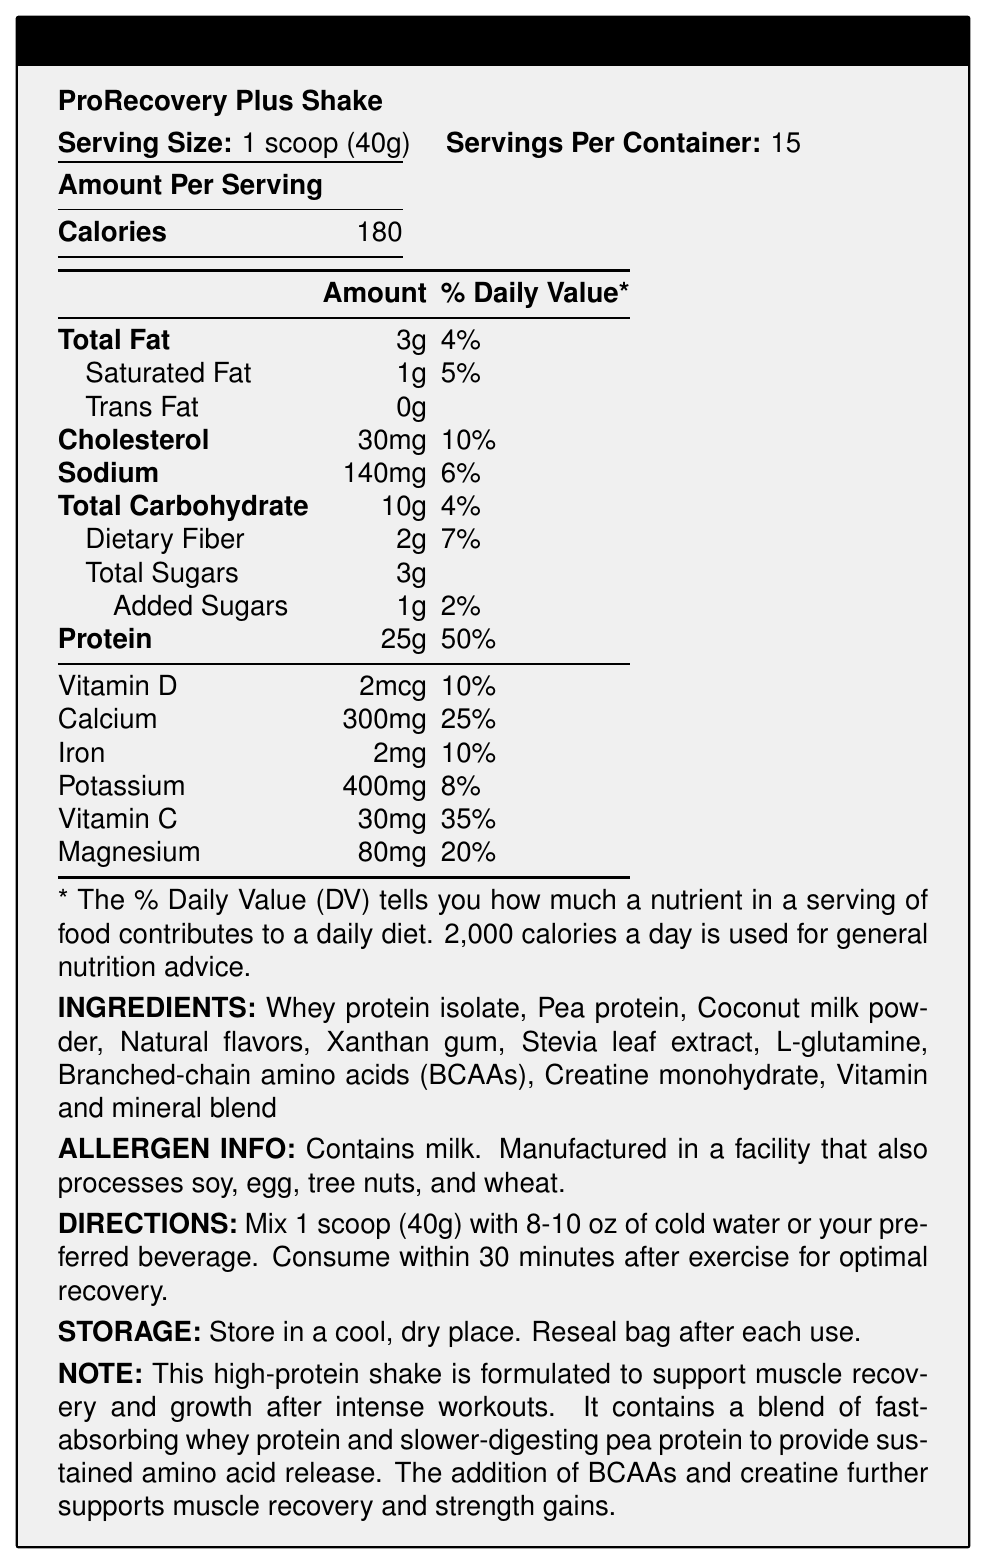what is the serving size of ProRecovery Plus Shake? The serving size is explicitly mentioned as "1 scoop (40g)" in the document.
Answer: 1 scoop (40g) how many servings are there per container? The document states that there are 15 servings per container.
Answer: 15 what is the total amount of protein per serving? It is clearly indicated that there are 25 grams of protein per serving.
Answer: 25g how many calories are in one serving? The document mentions that one serving contains 180 calories.
Answer: 180 what is the total carbohydrate content per serving in grams? The Total Carbohydrate content per serving is 10g as stated in the document.
Answer: 10g what is the percentage of daily value for calcium? The percentage daily value for calcium is indicated to be 25%.
Answer: 25% how much sodium is in each serving? The sodium content per serving is listed as 140 mg.
Answer: 140mg what kind of protein sources are included in the ingredients? The document lists "Whey protein isolate" and "Pea protein" as part of the ingredients.
Answer: Whey protein isolate and Pea protein what are the directions for consuming ProRecovery Plus Shake? The directions specify mixing 1 scoop with 8-10 oz of cold water or a preferred beverage and consuming within 30 minutes after exercise.
Answer: Mix 1 scoop (40g) with 8-10 oz of cold water or your preferred beverage. Consume within 30 minutes after exercise for optimal recovery. is there any added sugar in the product? The document specifies that the product contains 1g of added sugars.
Answer: Yes which of the following vitamins and minerals is NOT listed in the nutrition facts? A. Vitamin K B. Vitamin D C. Calcium D. Iron Vitamin K is not mentioned in the list of vitamins and minerals in the nutrition facts.
Answer: A. Vitamin K which ingredient is NOT listed in the allergen information? 1. Soy 2. Egg 3. Milk 4. Fish Fish is not mentioned in the allergen information section.
Answer: 4. Fish what percentage of daily value for protein does one serving provide? One serving provides 50% of the daily value for protein as indicated in the document.
Answer: 50% does the product contain any trans fat? The document indicates that the product contains 0 grams of trans fat.
Answer: No can this product be consumed by someone allergic to tree nuts? The allergen information states that it is manufactured in a facility that processes tree nuts.
Answer: No summarize the main idea of the document. The document outlines the key nutritional aspects, ingredient composition, allergen details, preparation instructions, and storage guidelines for the product.
Answer: The document provides the nutrition facts, ingredients, allergen information, directions for use, and storage instructions for "ProRecovery Plus Shake," a high-protein meal replacement shake designed for post-workout recovery. how much fiber is in one serving? The document states that there are 2 grams of dietary fiber per serving.
Answer: 2g what is the main benefit of consuming this shake after a workout? The document notes that the shake is formulated to support muscle recovery and growth after intense workouts.
Answer: To support muscle recovery and growth how many milligrams of vitamin C are in a serving? It is indicated in the document that there are 30 mg of Vitamin C per serving.
Answer: 30mg what flavors are used in the shake? The document states "Natural flavors" as one of the ingredients.
Answer: Natural flavors what are the storage instructions for the product? The storage instructions are clearly mentioned as storing in a cool, dry place and resealing the bag after each use.
Answer: Store in a cool, dry place. Reseal bag after each use. what is the total amount of sugar and added sugar per serving combined? The document lists 3g of total sugars and 1g of added sugars, which combined are 4g.
Answer: 4g what is the daily value percentage of vitamin D per serving? The percentage daily value for vitamin D is listed as 10%.
Answer: 10% how much cholesterol does one serving contain? Each serving contains 30 mg of cholesterol as noted in the document.
Answer: 30mg what is the primary target audience for this product? The document implies that the product is for post-workout recovery, targeting those interested in muscle recovery and growth.
Answer: People seeking post-workout recovery, likely those engaged in intense physical activity. 